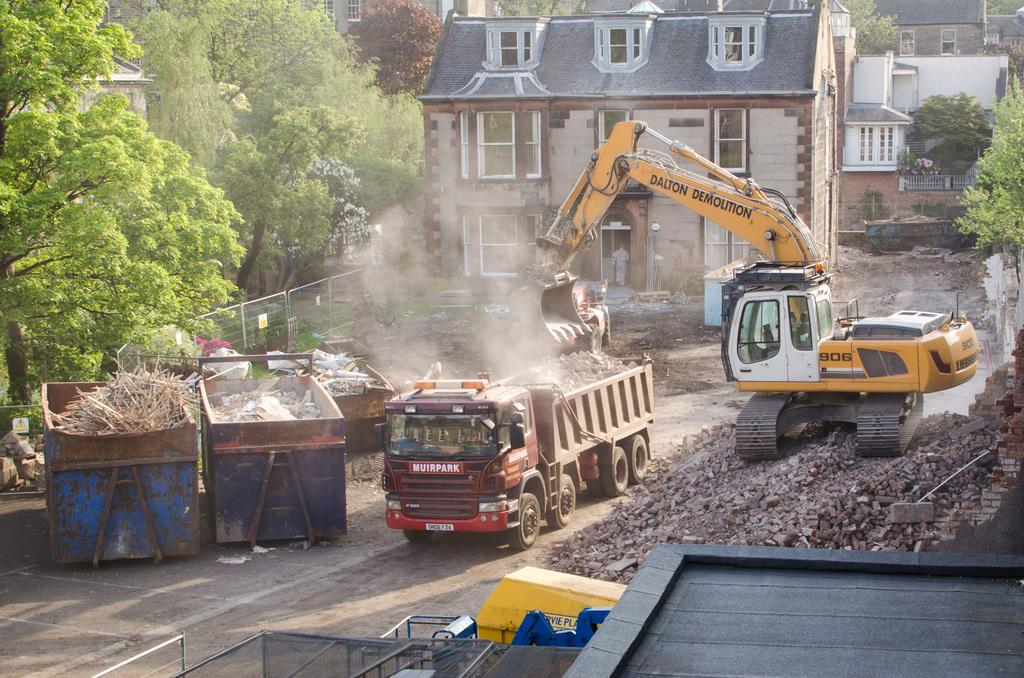What types of objects can be seen in the foreground of the image? There are vehicles, objects that resemble trash bins, and stones in the foreground of the image. What can be seen in the background of the image? There are trees and buildings in the background of the image. How many bottles can be seen in the image? There are no bottles present in the image. What type of animal is standing next to the trees in the background of the image? There are no animals, including donkeys, present in the image. 